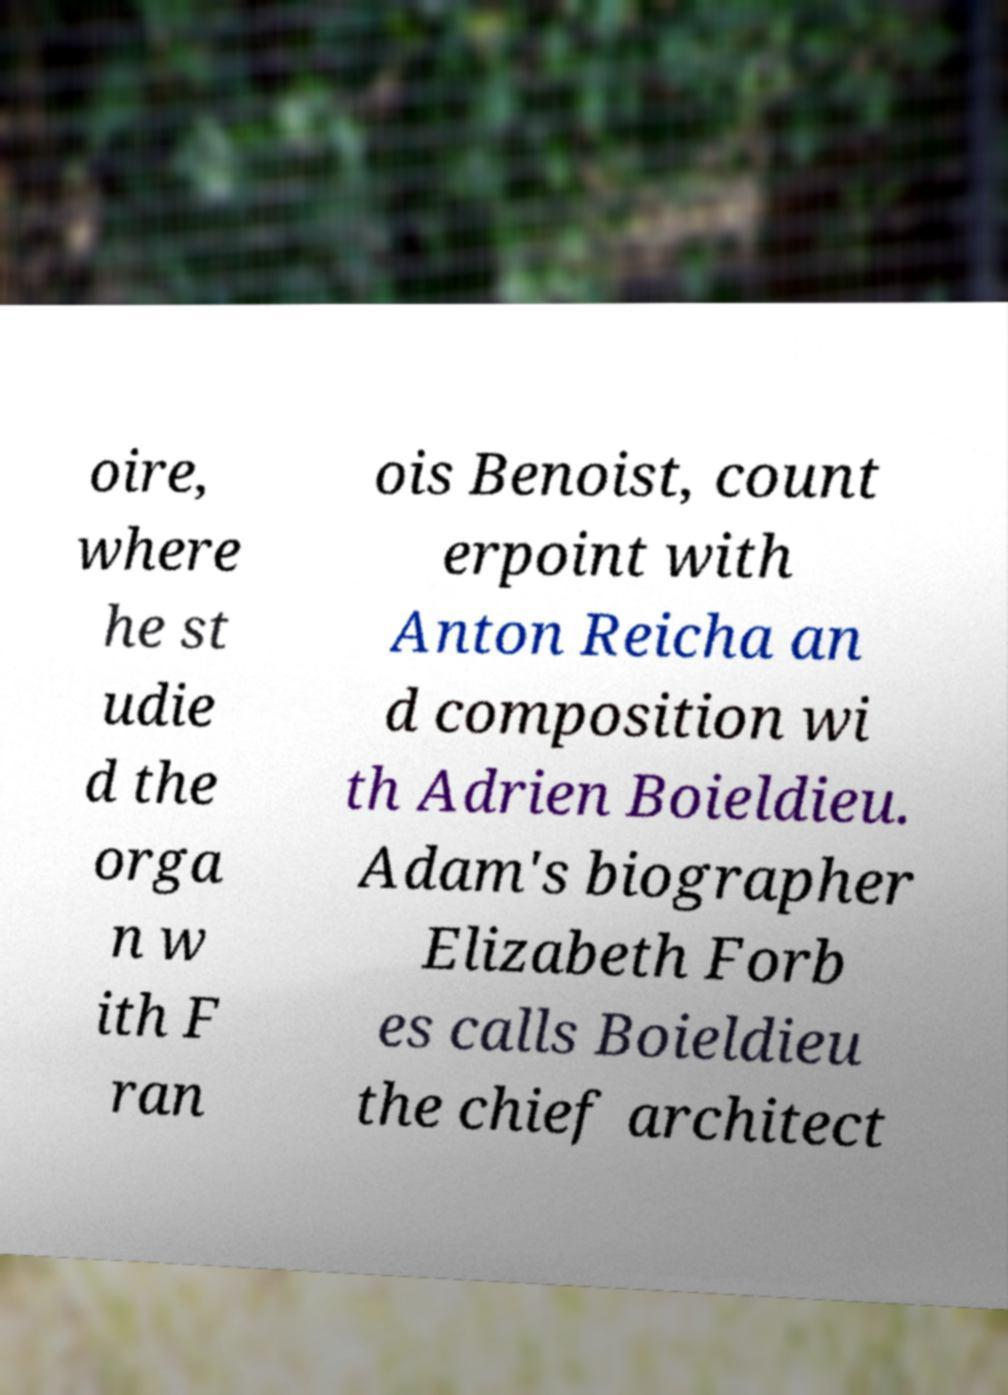Could you assist in decoding the text presented in this image and type it out clearly? oire, where he st udie d the orga n w ith F ran ois Benoist, count erpoint with Anton Reicha an d composition wi th Adrien Boieldieu. Adam's biographer Elizabeth Forb es calls Boieldieu the chief architect 